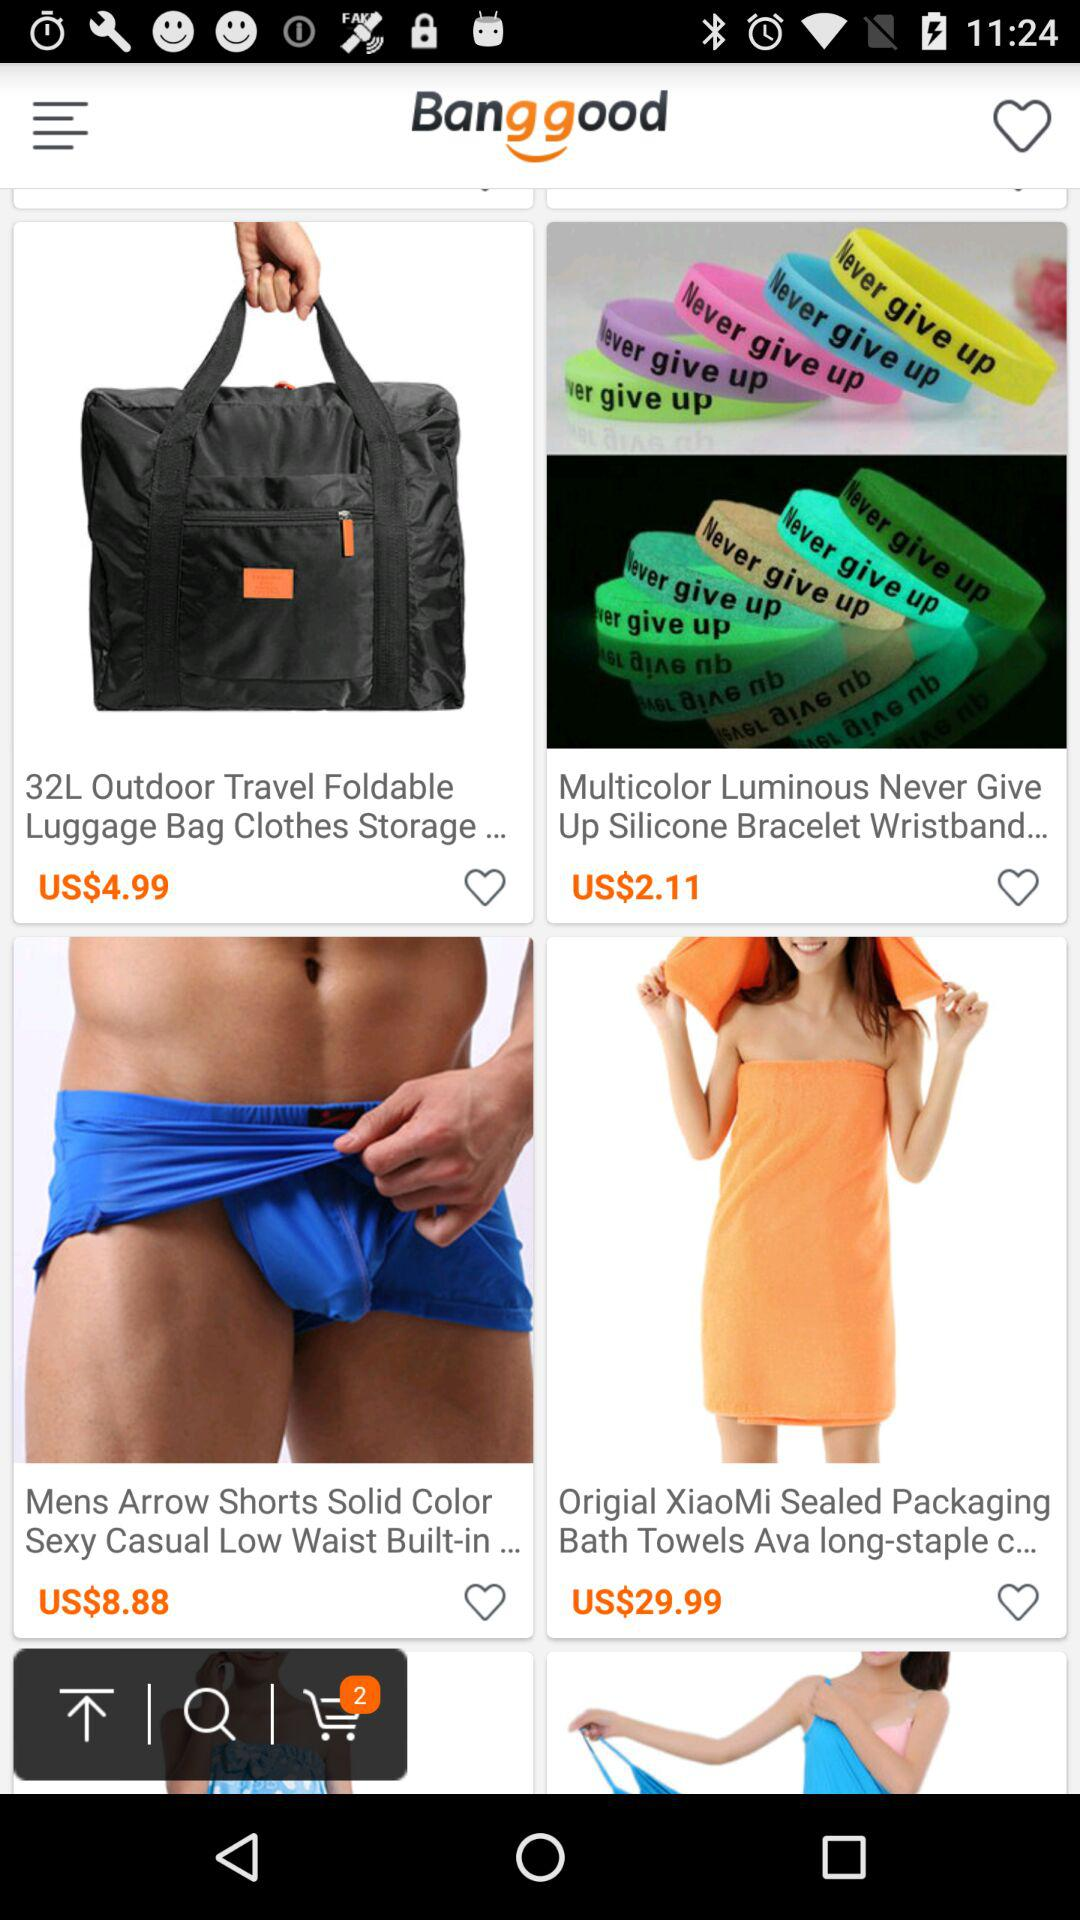How many items are there in the shopping cart?
Answer the question using a single word or phrase. 2 